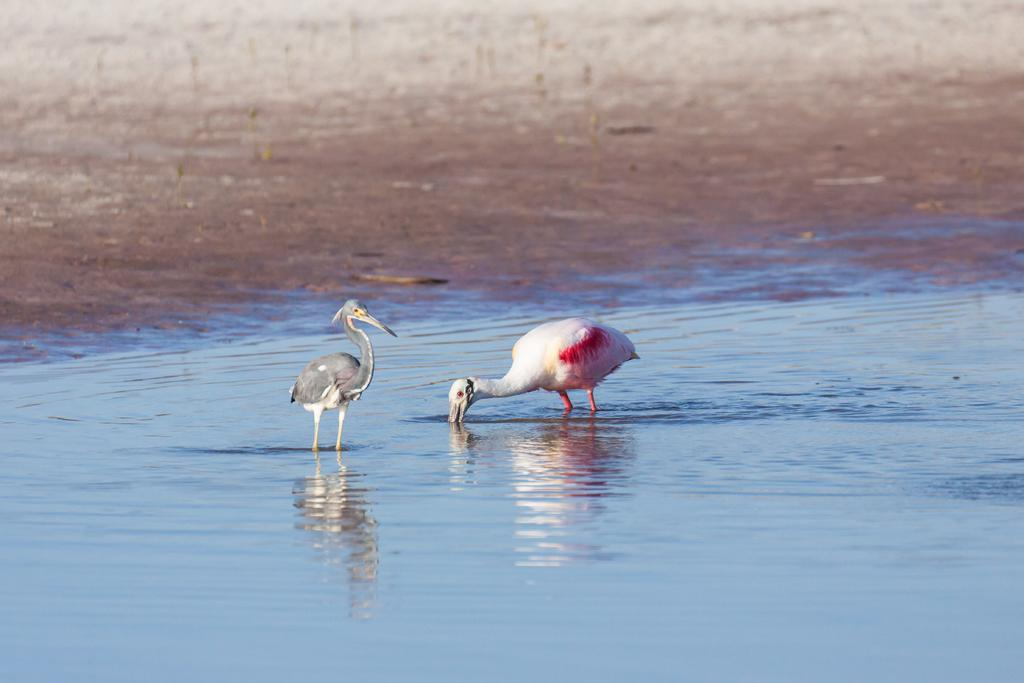What type of bird can be seen in the image? There is a white crane and a grey crane in the image. What are the birds doing in the image? The white crane is eating in the water, and the grey crane is standing in the water. Where are the birds located in the image? Both birds are in the water. What is the cause of the wren's sudden disappearance in the image? There is no wren present in the image, so it cannot be determined if it disappeared or if there was a cause for its disappearance. 